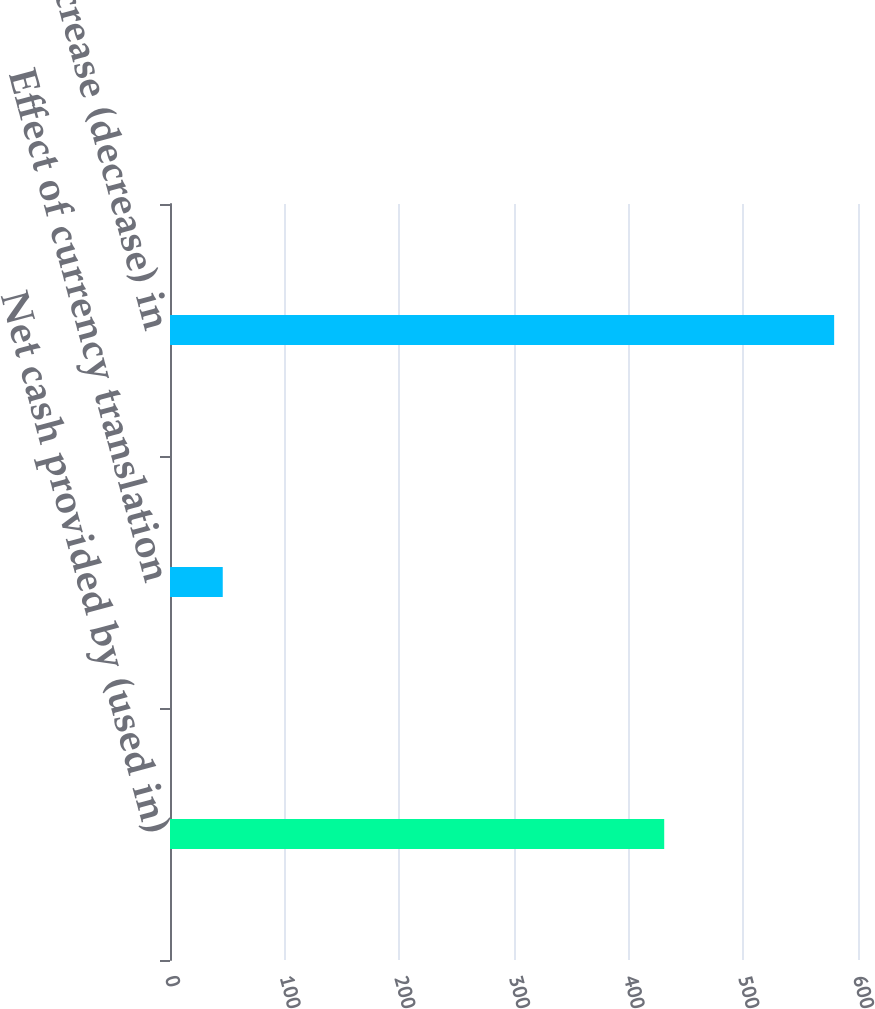Convert chart. <chart><loc_0><loc_0><loc_500><loc_500><bar_chart><fcel>Net cash provided by (used in)<fcel>Effect of currency translation<fcel>Net increase (decrease) in<nl><fcel>431<fcel>46<fcel>579.2<nl></chart> 